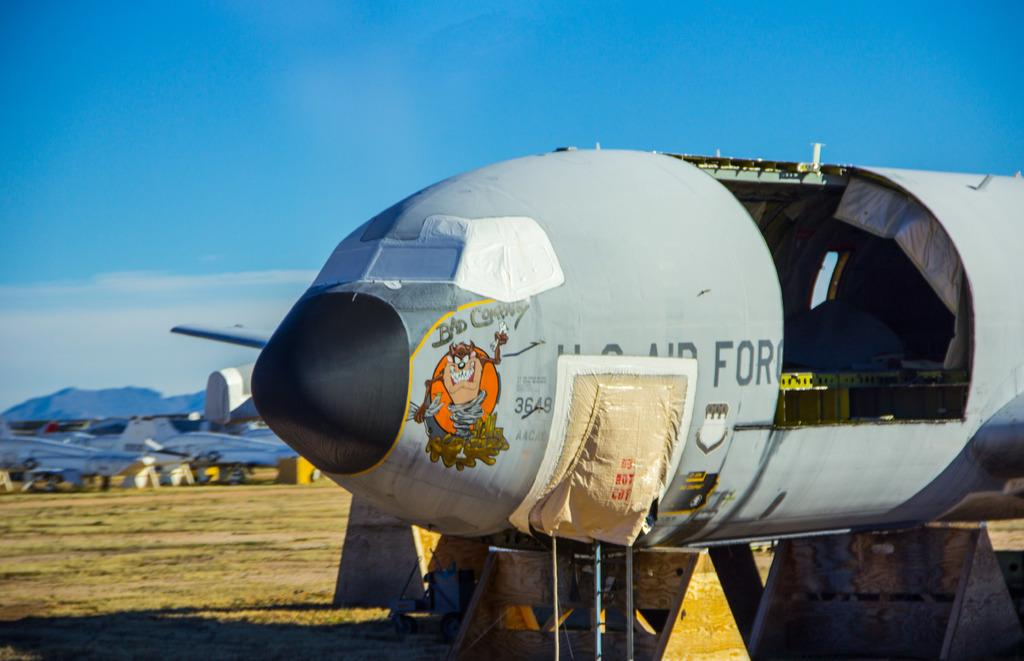Provide a one-sentence caption for the provided image. An aircraft in mid-repair features a Tasmanian Devil representation under the phrase "Bad Company". 